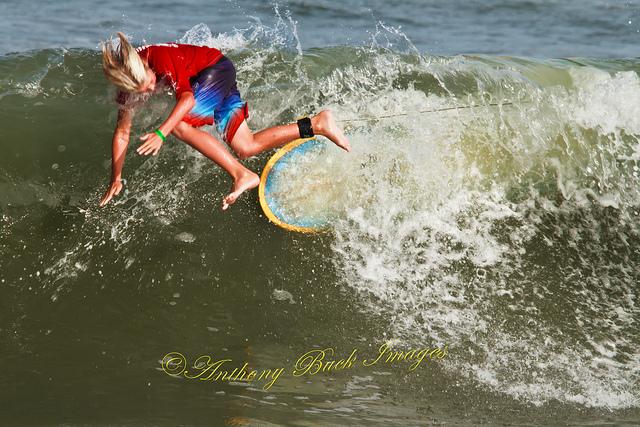What color is the surfboard?
Keep it brief. Blue and yellow. What is the color of the water?
Be succinct. Green. Is the surfer having a successful ride?
Be succinct. No. Is this person athletic?
Keep it brief. Yes. Why is the surfer suspended in the air?
Write a very short answer. Falling. Is the surfer wearing a ring?
Concise answer only. No. 